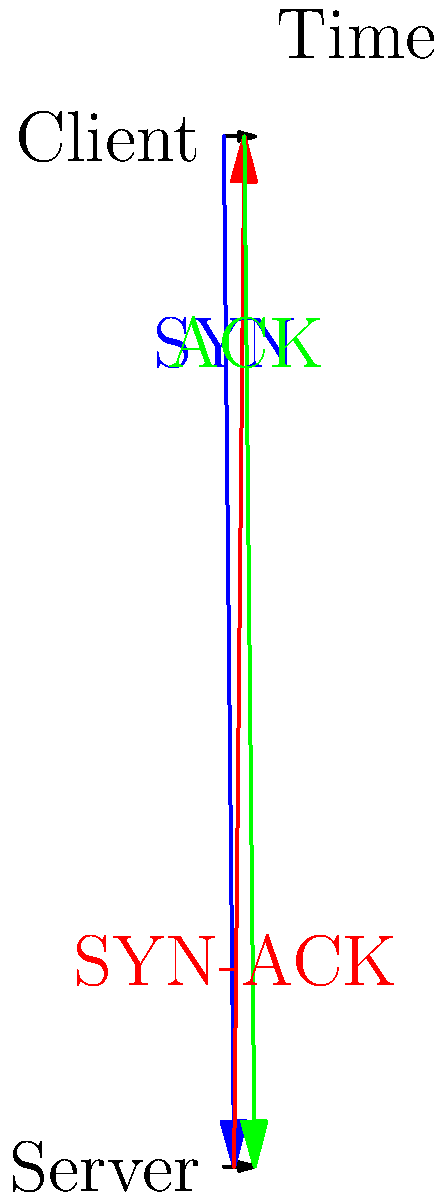In the TCP/IP handshake process illustrated above, what is the significance of the SYN-ACK packet sent from the server to the client, and how does it relate to the initial SYN packet? The TCP/IP handshake process, also known as the three-way handshake, establishes a reliable connection between a client and a server. Let's break down the process step-by-step:

1. The client initiates the connection by sending a SYN (synchronize) packet to the server. This packet contains an initial sequence number (ISN) for the client, let's call it $x$.

2. Upon receiving the SYN packet, the server responds with a SYN-ACK (synchronize-acknowledge) packet. This packet serves two purposes:
   a) It acknowledges the client's SYN packet by setting the acknowledgment number to $x+1$.
   b) It includes the server's own SYN with its initial sequence number, let's call it $y$.

3. The client then sends an ACK (acknowledge) packet back to the server, acknowledging the server's SYN-ACK. The acknowledgment number in this packet is set to $y+1$.

The significance of the SYN-ACK packet lies in its dual role:

1. Acknowledgment: It confirms to the client that the server has received the initial SYN packet.
2. Synchronization: It carries the server's own synchronization request to the client.

This packet is crucial because it combines two steps into one, making the handshake process more efficient. It relates to the initial SYN packet by directly responding to it and continuing the connection establishment process.

In network programming, understanding this process is essential for implementing reliable TCP connections and troubleshooting connection issues.
Answer: The SYN-ACK packet acknowledges the client's SYN and includes the server's own SYN, combining acknowledgment and synchronization in one step. 